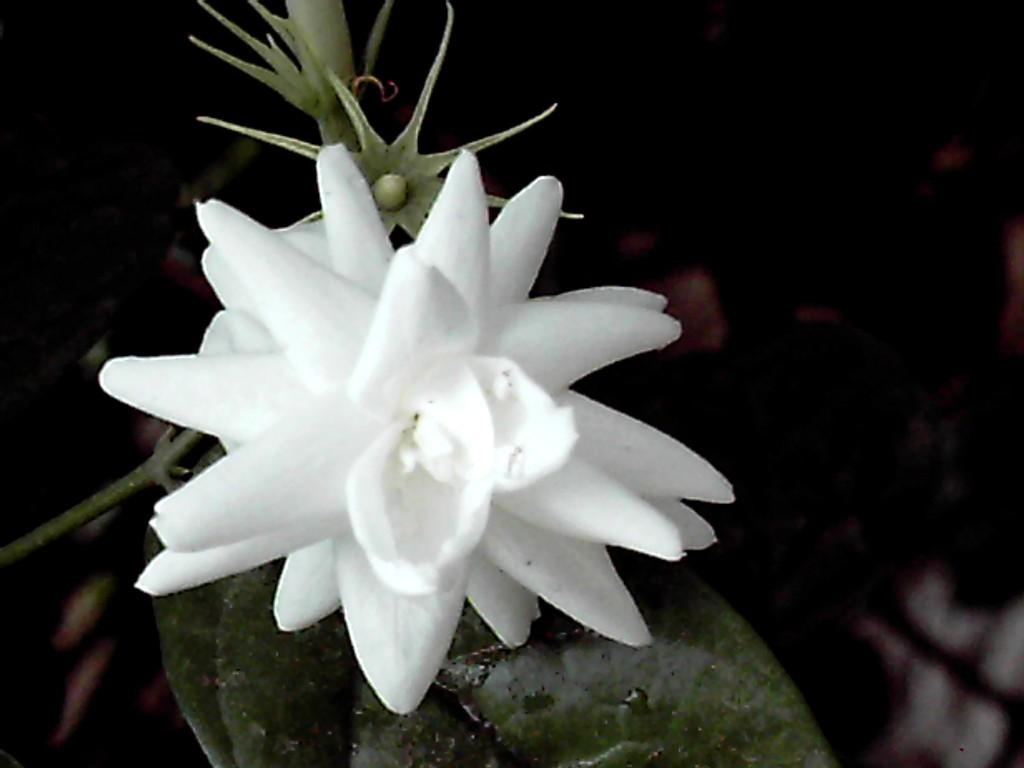What type of plant is visible in the image? There is a white flower plant in the image. What type of toys are scattered around the white flower plant in the image? There are no toys present in the image; it only features a white flower plant. 